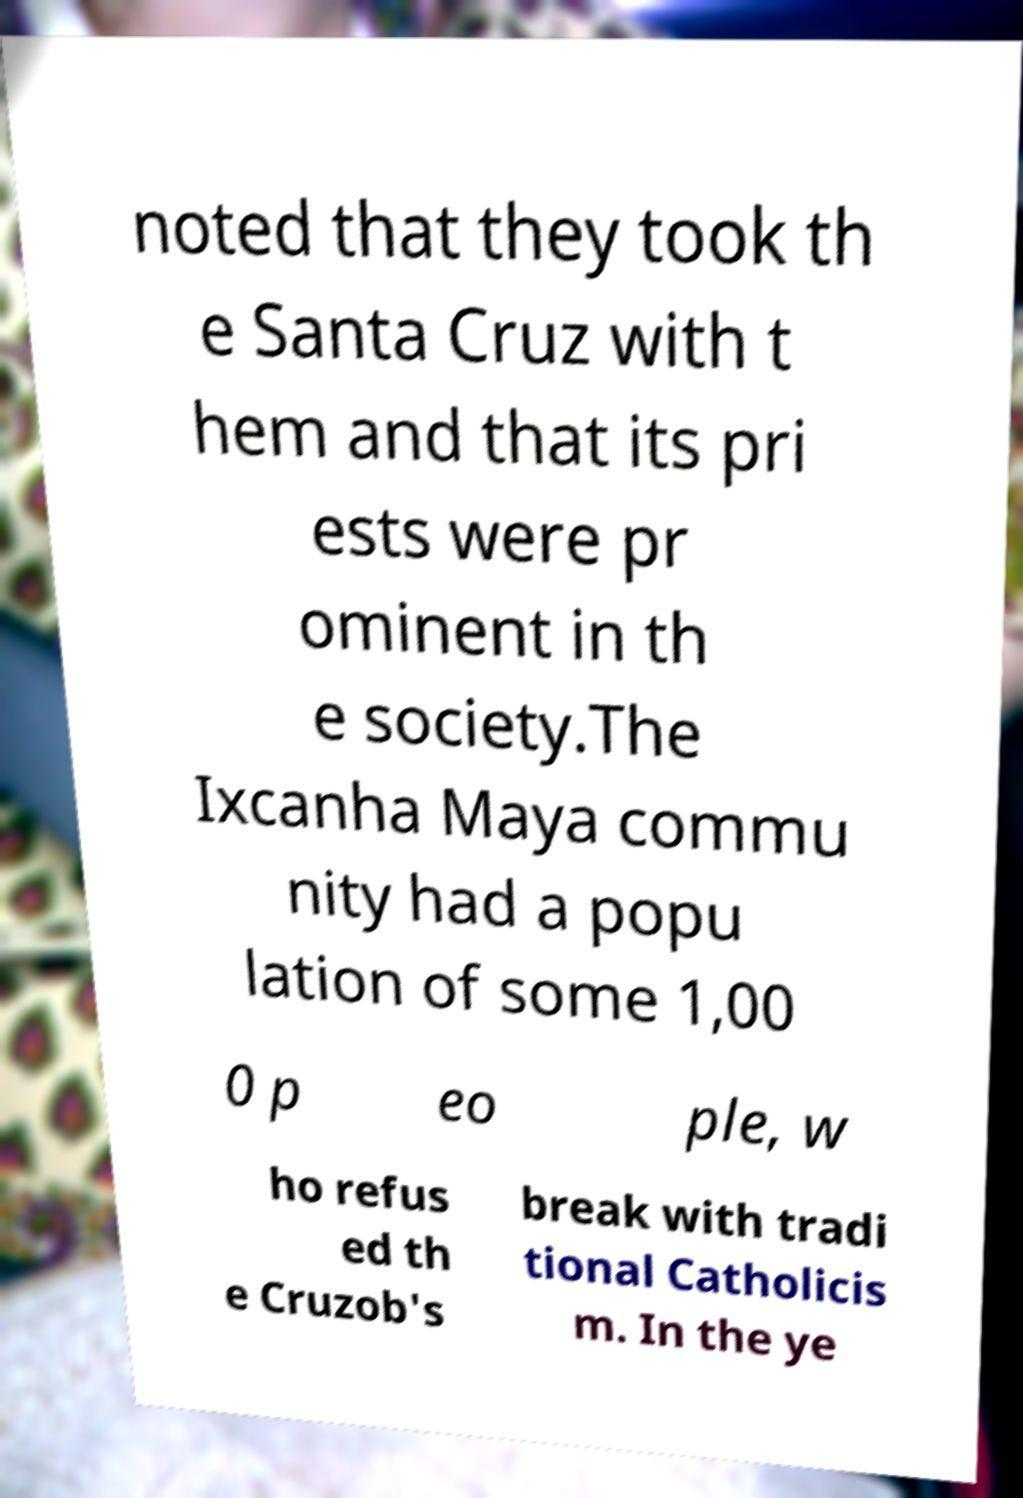Please identify and transcribe the text found in this image. noted that they took th e Santa Cruz with t hem and that its pri ests were pr ominent in th e society.The Ixcanha Maya commu nity had a popu lation of some 1,00 0 p eo ple, w ho refus ed th e Cruzob's break with tradi tional Catholicis m. In the ye 